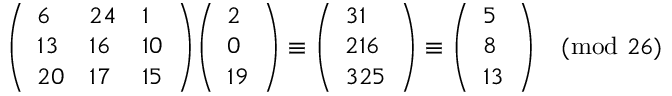Convert formula to latex. <formula><loc_0><loc_0><loc_500><loc_500>{ \left ( \begin{array} { l l l } { 6 } & { 2 4 } & { 1 } \\ { 1 3 } & { 1 6 } & { 1 0 } \\ { 2 0 } & { 1 7 } & { 1 5 } \end{array} \right ) } { \left ( \begin{array} { l } { 2 } \\ { 0 } \\ { 1 9 } \end{array} \right ) } \equiv \left ( \begin{array} { l } { 3 1 } \\ { 2 1 6 } \\ { 3 2 5 } \end{array} \right ) \equiv \left ( \begin{array} { l } { 5 } \\ { 8 } \\ { 1 3 } \end{array} \right ) { \pmod { 2 6 } }</formula> 